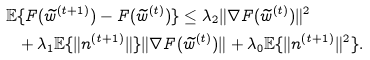Convert formula to latex. <formula><loc_0><loc_0><loc_500><loc_500>\mathbb { E } & \{ F ( \widetilde { w } ^ { ( t + 1 ) } ) - F ( \widetilde { w } ^ { ( t ) } ) \} \leq \lambda _ { 2 } \| \nabla F ( \widetilde { w } ^ { ( t ) } ) \| ^ { 2 } \\ & + \lambda _ { 1 } \mathbb { E } \{ \| n ^ { ( t + 1 ) } \| \} \| \nabla F ( \widetilde { w } ^ { ( t ) } ) \| + \lambda _ { 0 } \mathbb { E } \{ \| n ^ { ( t + 1 ) } \| ^ { 2 } \} .</formula> 